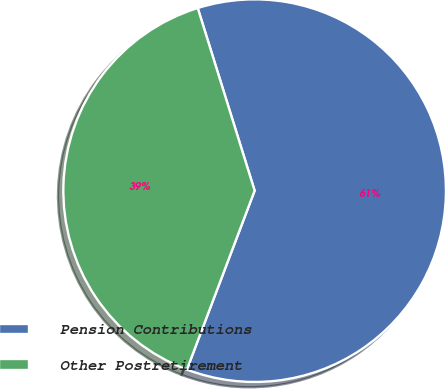<chart> <loc_0><loc_0><loc_500><loc_500><pie_chart><fcel>Pension Contributions<fcel>Other Postretirement<nl><fcel>60.57%<fcel>39.43%<nl></chart> 